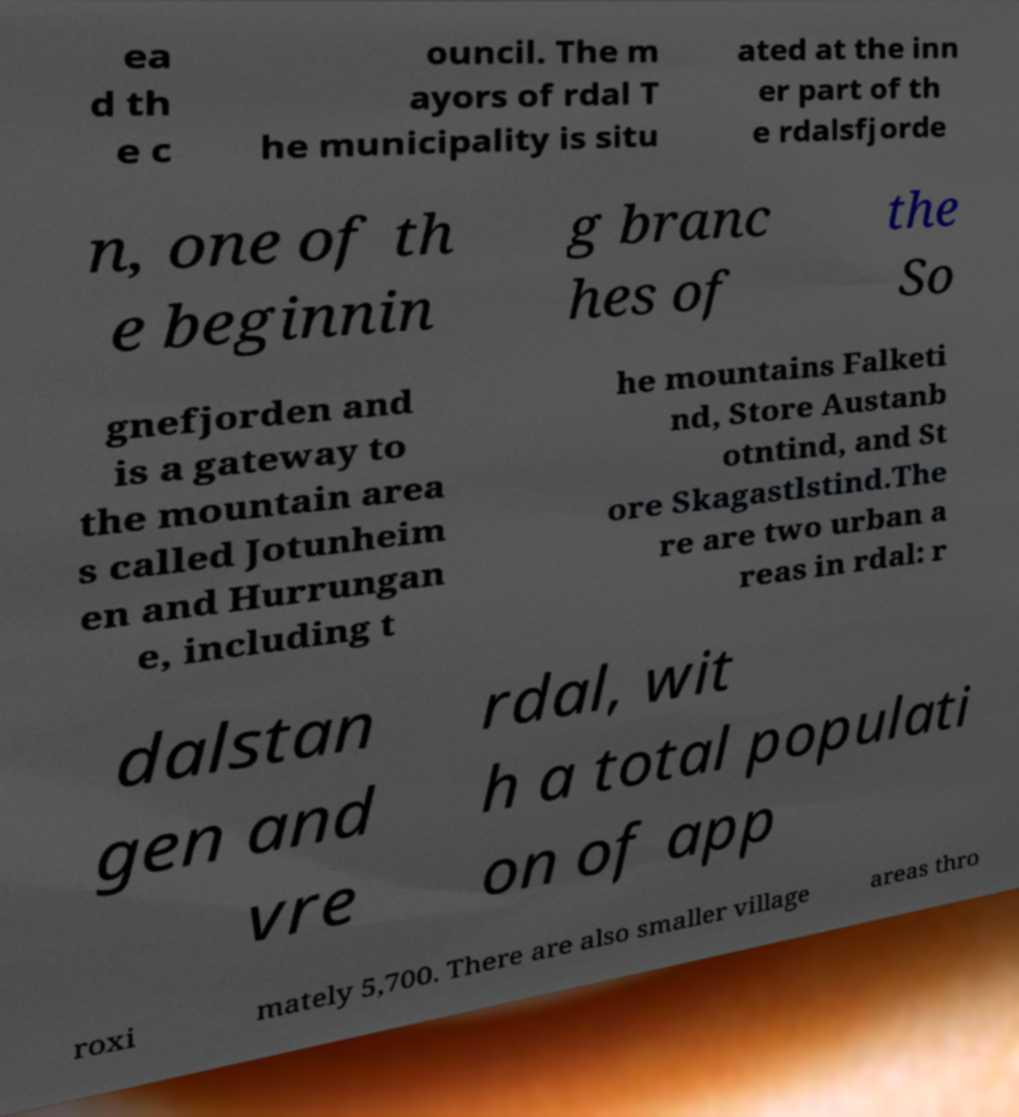There's text embedded in this image that I need extracted. Can you transcribe it verbatim? ea d th e c ouncil. The m ayors of rdal T he municipality is situ ated at the inn er part of th e rdalsfjorde n, one of th e beginnin g branc hes of the So gnefjorden and is a gateway to the mountain area s called Jotunheim en and Hurrungan e, including t he mountains Falketi nd, Store Austanb otntind, and St ore Skagastlstind.The re are two urban a reas in rdal: r dalstan gen and vre rdal, wit h a total populati on of app roxi mately 5,700. There are also smaller village areas thro 